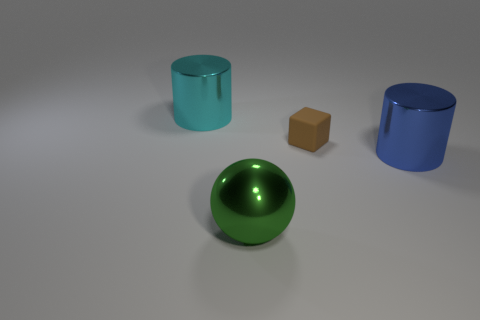How could the objects be used in a real-life setting? The green ball could be a decorative element or used in games or as a part of a machine that requires spherical parts. The two cylinders could serve as containers or stands, while the cube might be used as a simple toy, a paperweight, or a model for educational purposes. 